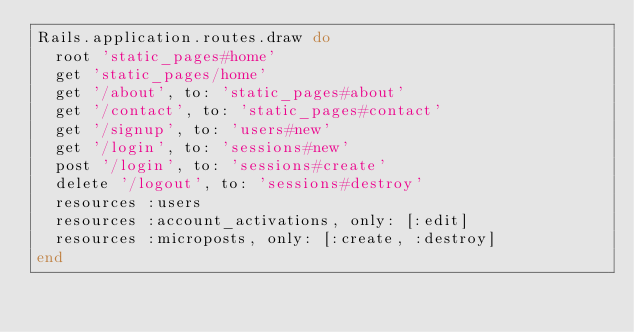<code> <loc_0><loc_0><loc_500><loc_500><_Ruby_>Rails.application.routes.draw do
  root 'static_pages#home'
  get 'static_pages/home'
  get '/about', to: 'static_pages#about'
  get '/contact', to: 'static_pages#contact'
  get '/signup', to: 'users#new'
  get '/login', to: 'sessions#new'
  post '/login', to: 'sessions#create'
  delete '/logout', to: 'sessions#destroy'
  resources :users
  resources :account_activations, only: [:edit]
  resources :microposts, only: [:create, :destroy]
end
</code> 